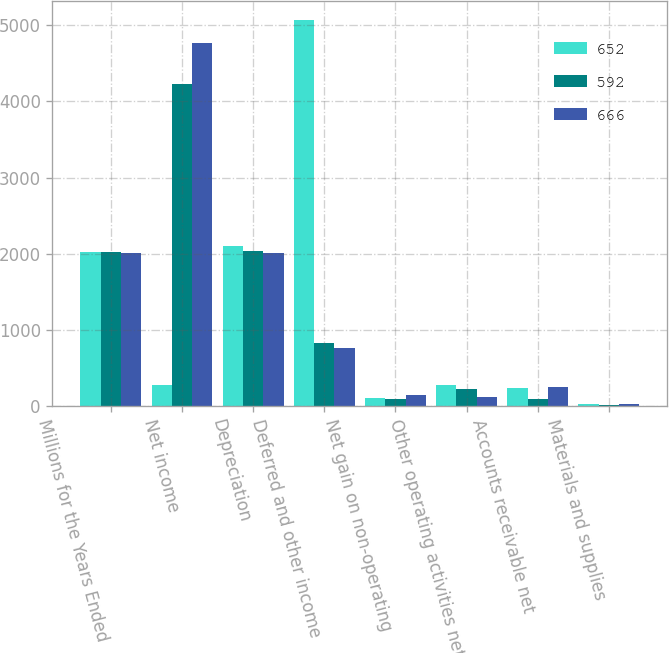Convert chart. <chart><loc_0><loc_0><loc_500><loc_500><stacked_bar_chart><ecel><fcel>Millions for the Years Ended<fcel>Net income<fcel>Depreciation<fcel>Deferred and other income<fcel>Net gain on non-operating<fcel>Other operating activities net<fcel>Accounts receivable net<fcel>Materials and supplies<nl><fcel>652<fcel>2017<fcel>282<fcel>2105<fcel>5067<fcel>111<fcel>282<fcel>235<fcel>32<nl><fcel>592<fcel>2016<fcel>4233<fcel>2038<fcel>831<fcel>94<fcel>228<fcel>98<fcel>19<nl><fcel>666<fcel>2015<fcel>4772<fcel>2012<fcel>765<fcel>144<fcel>116<fcel>255<fcel>24<nl></chart> 